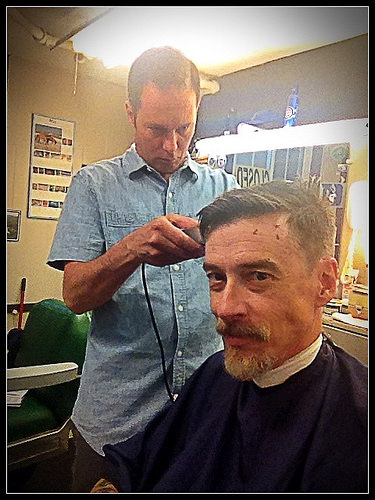<image>
Is there a sign to the left of the hairdresser? Yes. From this viewpoint, the sign is positioned to the left side relative to the hairdresser. 